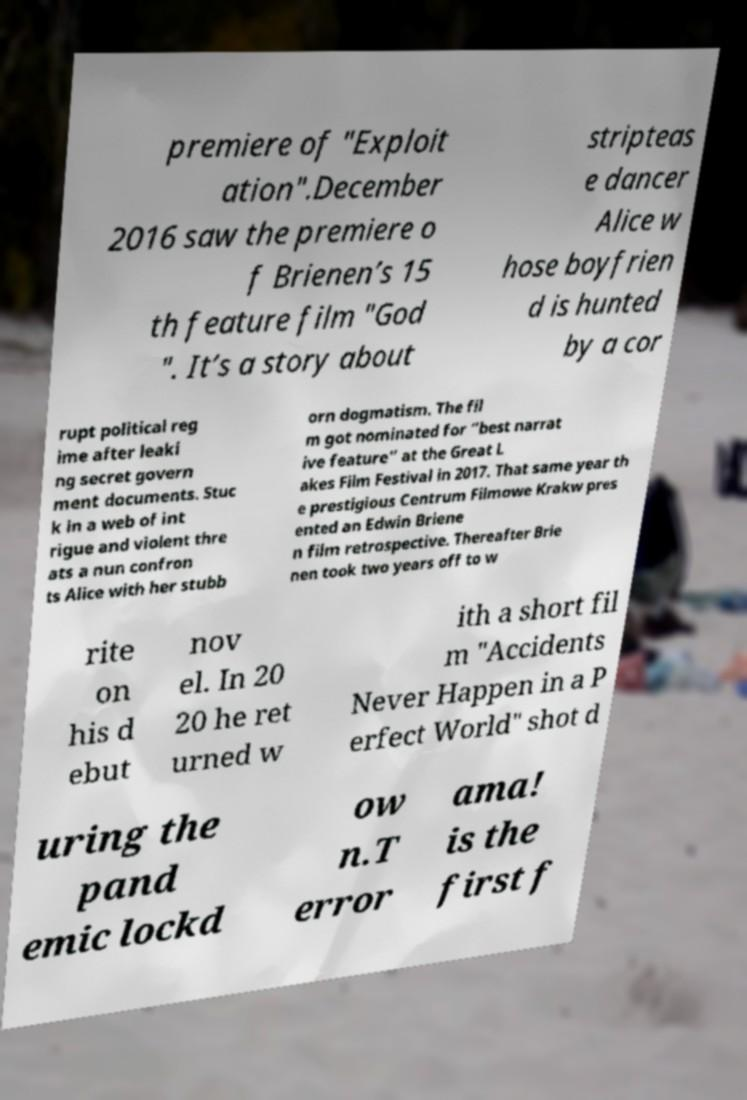Can you read and provide the text displayed in the image?This photo seems to have some interesting text. Can you extract and type it out for me? premiere of "Exploit ation".December 2016 saw the premiere o f Brienen’s 15 th feature film "God ". It’s a story about stripteas e dancer Alice w hose boyfrien d is hunted by a cor rupt political reg ime after leaki ng secret govern ment documents. Stuc k in a web of int rigue and violent thre ats a nun confron ts Alice with her stubb orn dogmatism. The fil m got nominated for “best narrat ive feature” at the Great L akes Film Festival in 2017. That same year th e prestigious Centrum Filmowe Krakw pres ented an Edwin Briene n film retrospective. Thereafter Brie nen took two years off to w rite on his d ebut nov el. In 20 20 he ret urned w ith a short fil m "Accidents Never Happen in a P erfect World" shot d uring the pand emic lockd ow n.T error ama! is the first f 